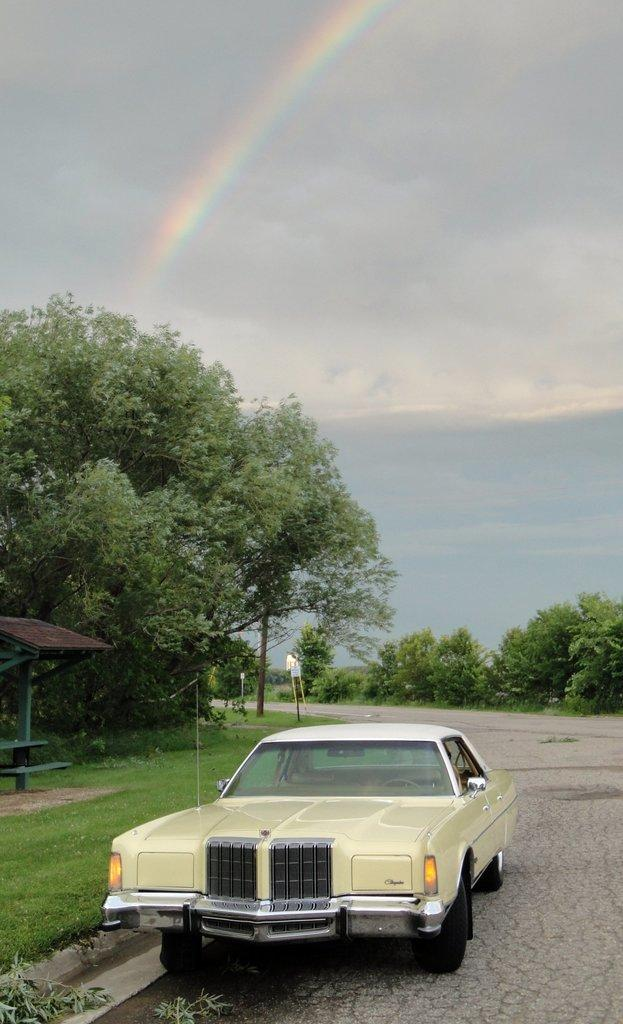What is the main subject of the image? There is a car on a road in the image. What can be seen beside the car? There is a grassland beside the car. What is visible in the background of the image? There are trees and the sky in the background of the image. What additional feature can be seen in the sky? There is a rainbow in the sky. Can you tell me how many quarters are visible on the car in the image? There are no quarters visible on the car in the image. What type of moon can be seen in the image? There is no moon present in the image; it features a car on a road with a grassland, trees, and a rainbow in the sky. 